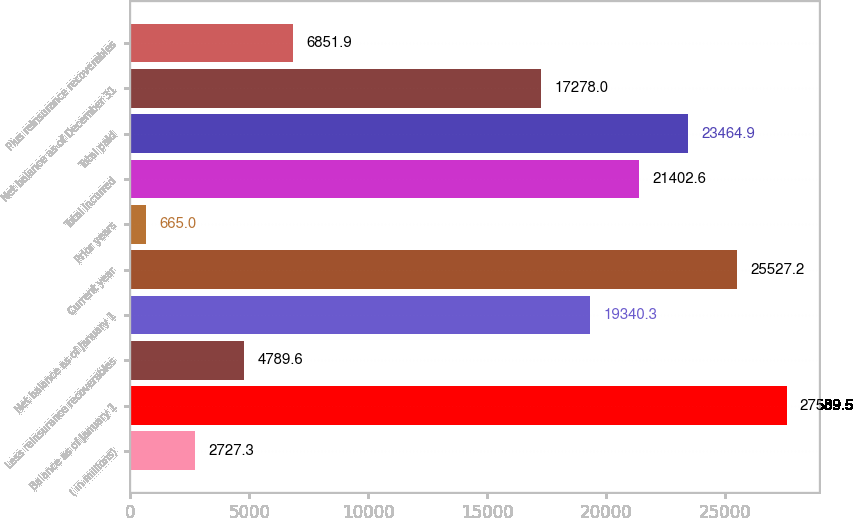Convert chart to OTSL. <chart><loc_0><loc_0><loc_500><loc_500><bar_chart><fcel>( in millions)<fcel>Balance as of January 1<fcel>Less reinsurance recoverables<fcel>Net balance as of January 1<fcel>Current year<fcel>Prior years<fcel>Total incurred<fcel>Total paid<fcel>Net balance as of December 31<fcel>Plus reinsurance recoverables<nl><fcel>2727.3<fcel>27589.5<fcel>4789.6<fcel>19340.3<fcel>25527.2<fcel>665<fcel>21402.6<fcel>23464.9<fcel>17278<fcel>6851.9<nl></chart> 